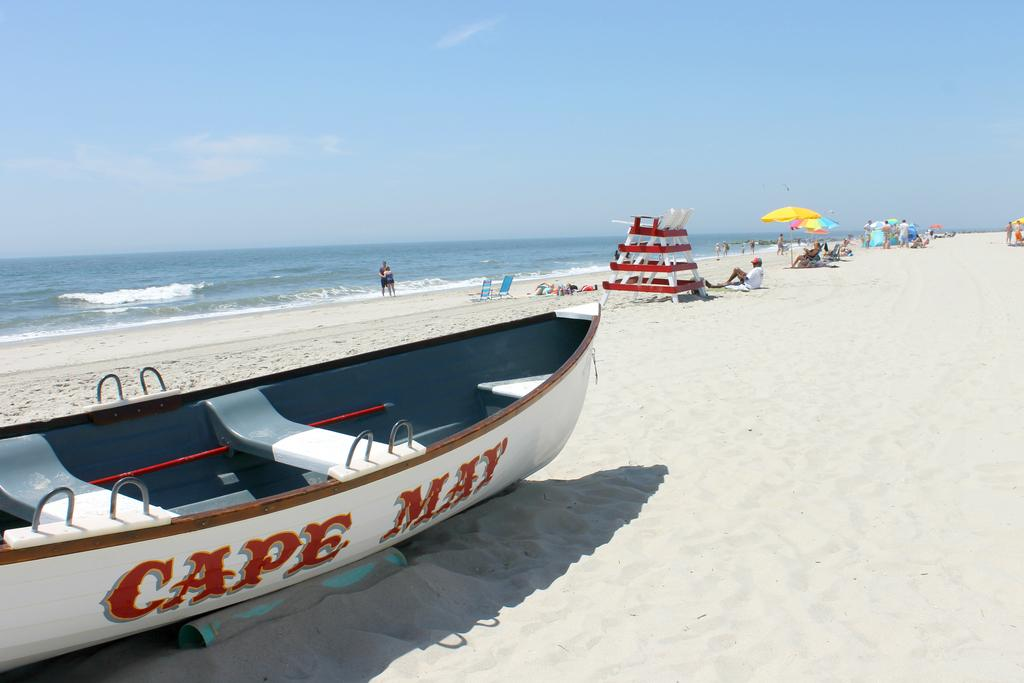What is located on the sand in the image? There is a boat on the sand in the image. Who or what can be seen in the image besides the boat? There are people visible in the image. What is visible in the background of the image? There is an ocean in the background of the image. What can be seen in the sky in the image? There are clouds in the sky in the image. How many clocks are hanging on the boat in the image? There are no clocks visible in the image. 